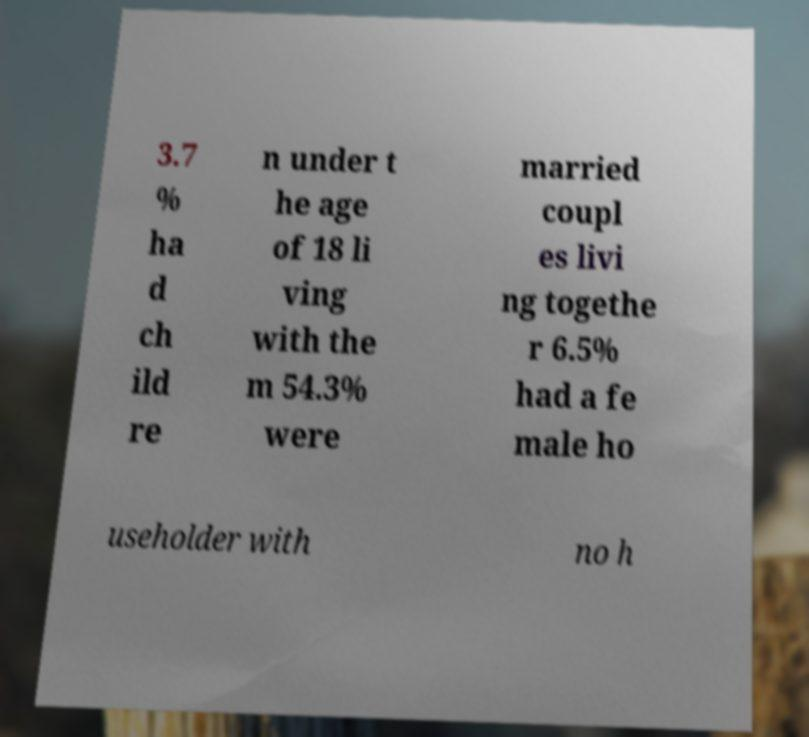What messages or text are displayed in this image? I need them in a readable, typed format. 3.7 % ha d ch ild re n under t he age of 18 li ving with the m 54.3% were married coupl es livi ng togethe r 6.5% had a fe male ho useholder with no h 